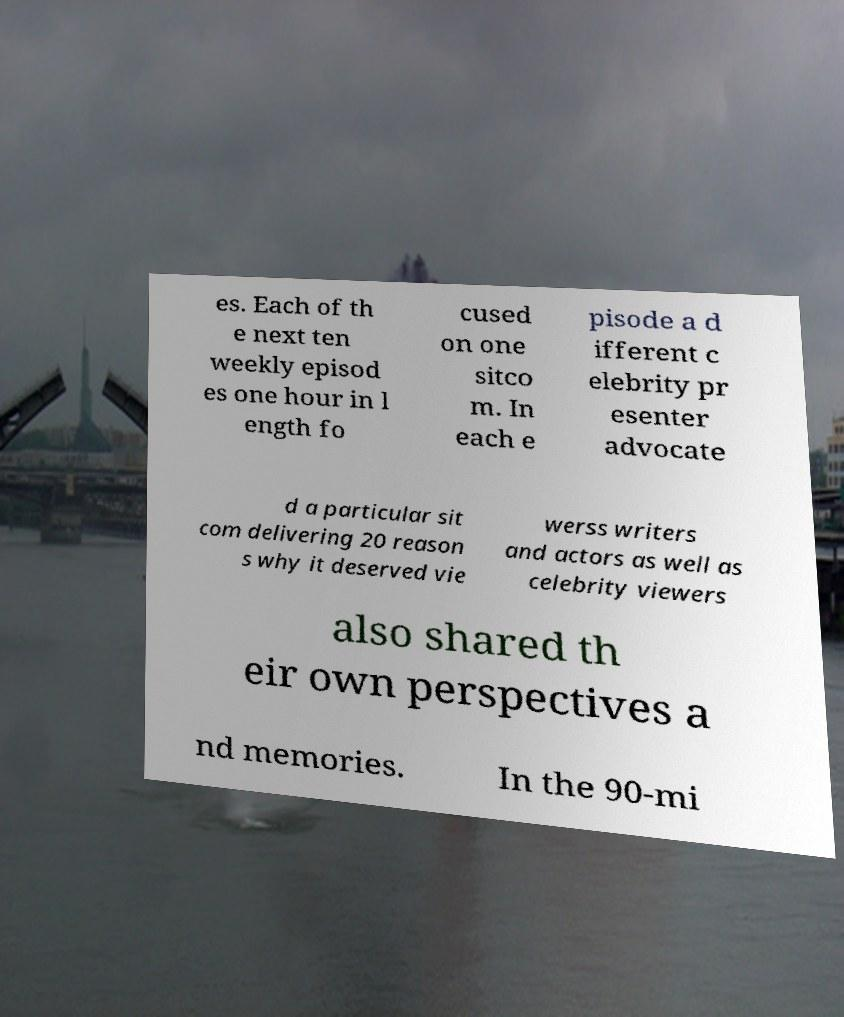Can you accurately transcribe the text from the provided image for me? es. Each of th e next ten weekly episod es one hour in l ength fo cused on one sitco m. In each e pisode a d ifferent c elebrity pr esenter advocate d a particular sit com delivering 20 reason s why it deserved vie werss writers and actors as well as celebrity viewers also shared th eir own perspectives a nd memories. In the 90-mi 